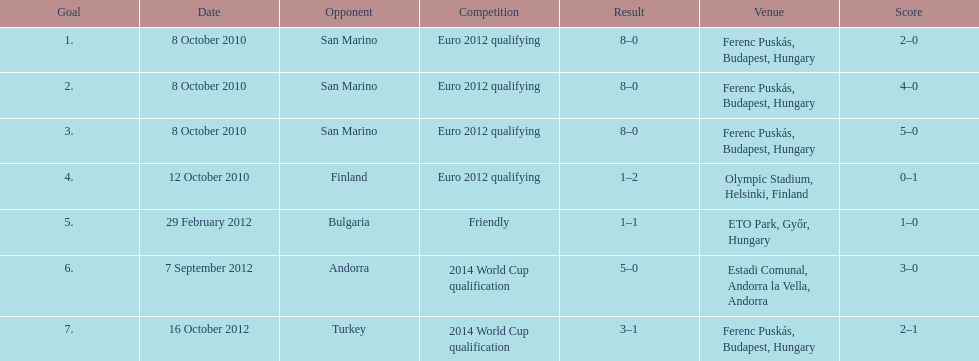How many goals were scored at the euro 2012 qualifying competition? 12. 